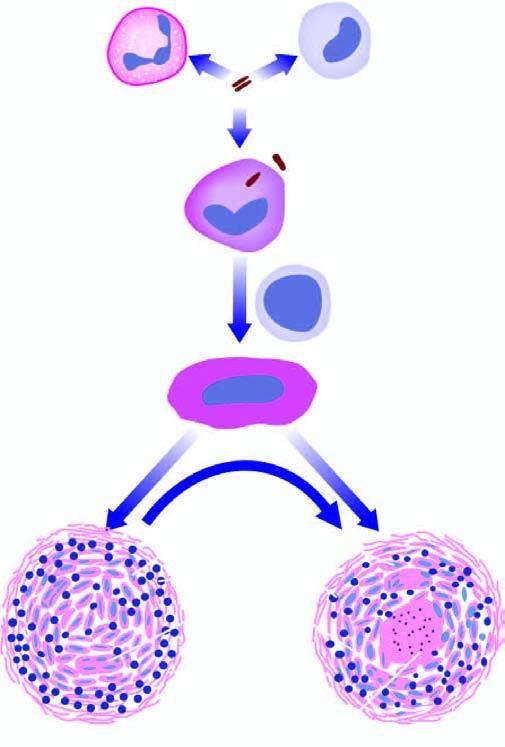what is composed of granular caseation necrosis, surrounded by epithelioid cells and langhans ' giant cells and peripheral rim of lymphocytes bounded by fibroblasts in fully formed granuloma?
Answer the question using a single word or phrase. Centre 